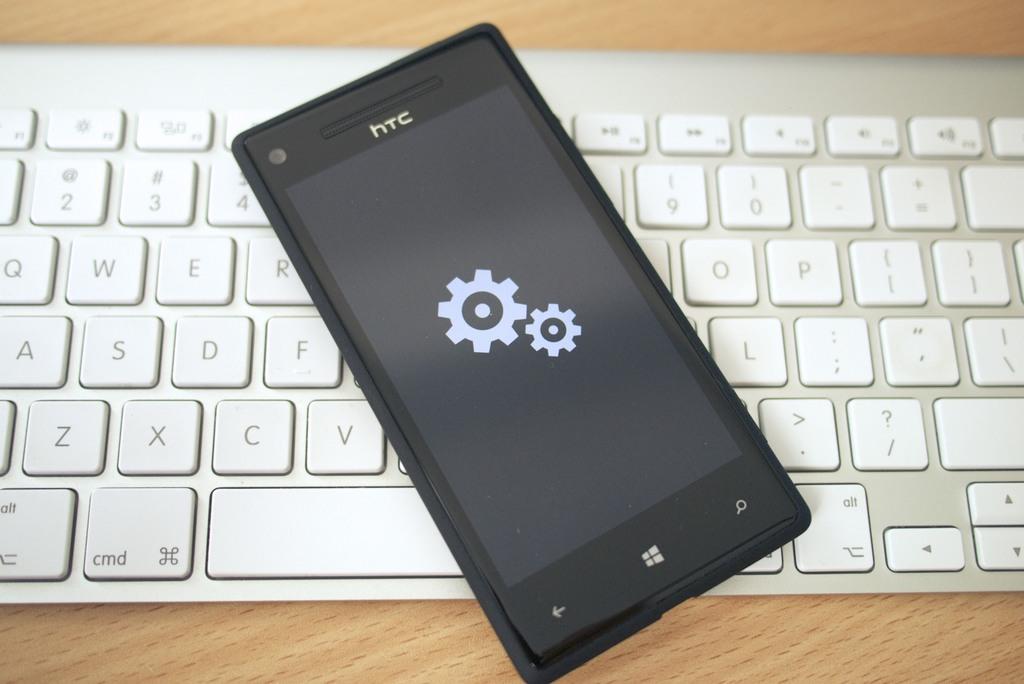What type of key is to the left of the spacebar?
Offer a very short reply. Cmd. What brand is the smart phone?
Give a very brief answer. Htc. 